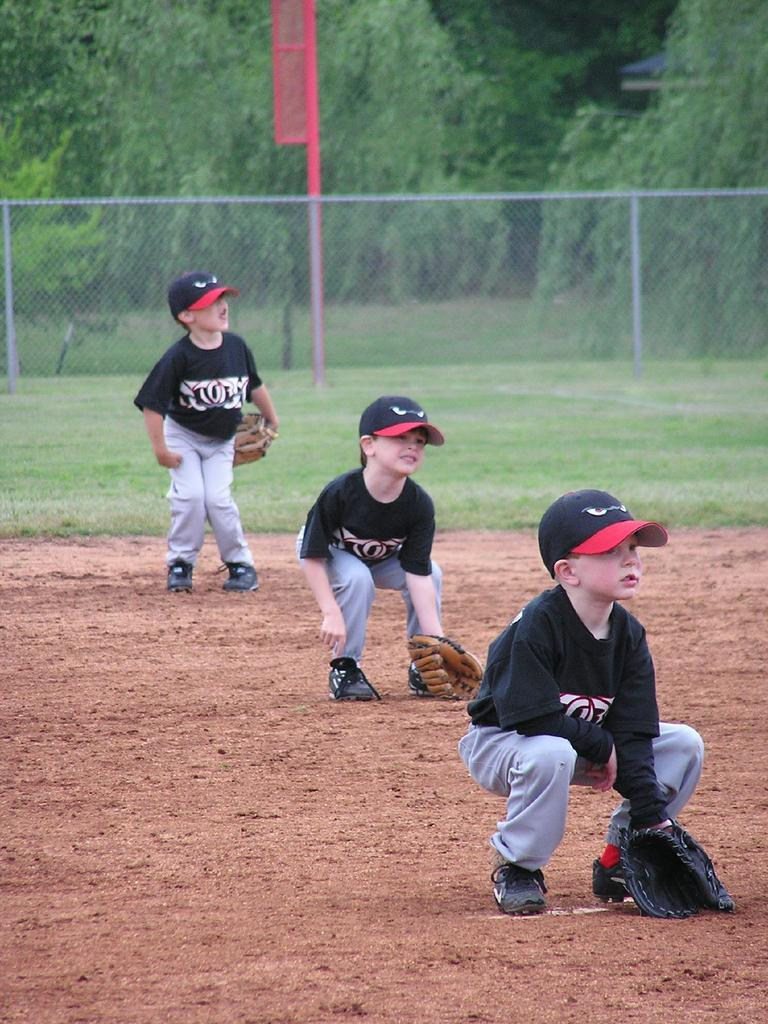How many people are in the image? There are three people in the image. What colors are the people wearing? The people are wearing black and ash color dresses. What headgear are the people wearing? The people are wearing caps. What type of hand covering are the people wearing? The people are wearing gloves. What can be seen in the background of the image? There is a net fence, poles, and many trees in the background of the image. What type of cloud can be seen in the image? There is no cloud visible in the image; the sky is not mentioned in the provided facts. 